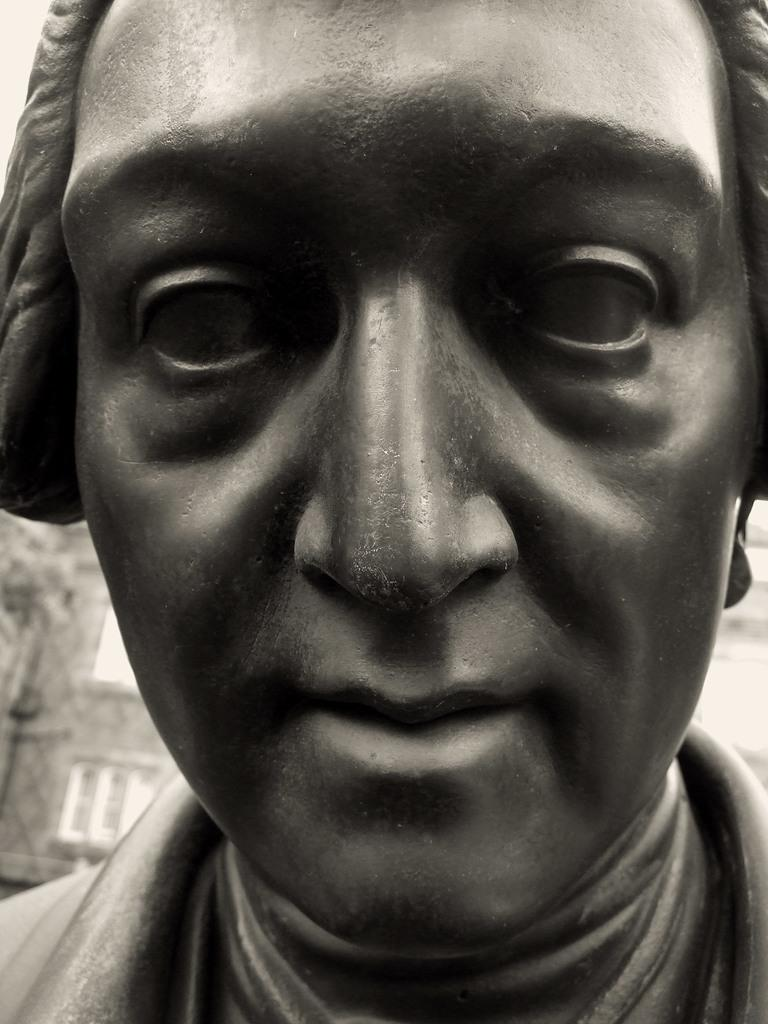What is the main subject of the image? There is a sculpture of a person in the image. Can you describe the setting of the image? There is a building in the background of the image. What type of mint can be seen growing near the sculpture in the image? There is no mint present in the image; it only features a sculpture of a person and a building in the background. 